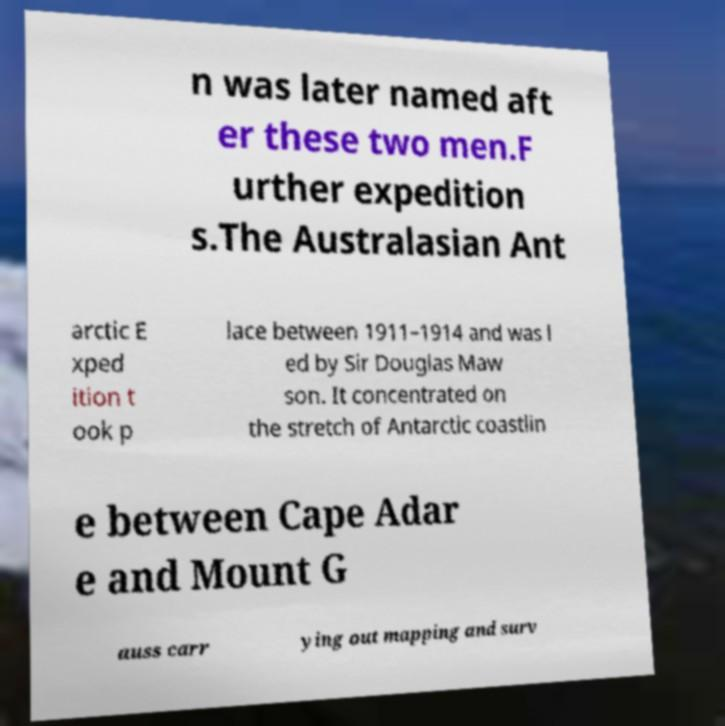For documentation purposes, I need the text within this image transcribed. Could you provide that? n was later named aft er these two men.F urther expedition s.The Australasian Ant arctic E xped ition t ook p lace between 1911–1914 and was l ed by Sir Douglas Maw son. It concentrated on the stretch of Antarctic coastlin e between Cape Adar e and Mount G auss carr ying out mapping and surv 